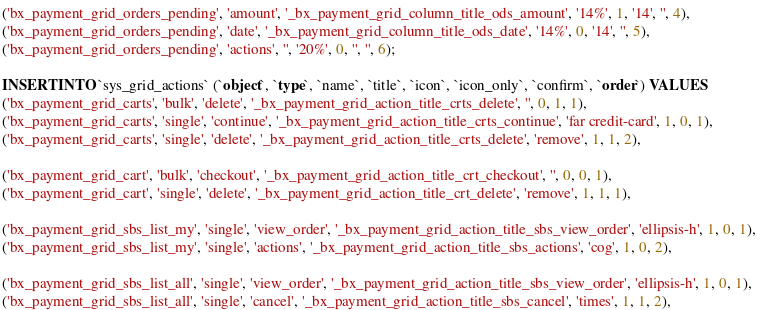Convert code to text. <code><loc_0><loc_0><loc_500><loc_500><_SQL_>('bx_payment_grid_orders_pending', 'amount', '_bx_payment_grid_column_title_ods_amount', '14%', 1, '14', '', 4),
('bx_payment_grid_orders_pending', 'date', '_bx_payment_grid_column_title_ods_date', '14%', 0, '14', '', 5),
('bx_payment_grid_orders_pending', 'actions', '', '20%', 0, '', '', 6);

INSERT INTO `sys_grid_actions` (`object`, `type`, `name`, `title`, `icon`, `icon_only`, `confirm`, `order`) VALUES
('bx_payment_grid_carts', 'bulk', 'delete', '_bx_payment_grid_action_title_crts_delete', '', 0, 1, 1),
('bx_payment_grid_carts', 'single', 'continue', '_bx_payment_grid_action_title_crts_continue', 'far credit-card', 1, 0, 1),
('bx_payment_grid_carts', 'single', 'delete', '_bx_payment_grid_action_title_crts_delete', 'remove', 1, 1, 2),

('bx_payment_grid_cart', 'bulk', 'checkout', '_bx_payment_grid_action_title_crt_checkout', '', 0, 0, 1),
('bx_payment_grid_cart', 'single', 'delete', '_bx_payment_grid_action_title_crt_delete', 'remove', 1, 1, 1),

('bx_payment_grid_sbs_list_my', 'single', 'view_order', '_bx_payment_grid_action_title_sbs_view_order', 'ellipsis-h', 1, 0, 1),
('bx_payment_grid_sbs_list_my', 'single', 'actions', '_bx_payment_grid_action_title_sbs_actions', 'cog', 1, 0, 2),

('bx_payment_grid_sbs_list_all', 'single', 'view_order', '_bx_payment_grid_action_title_sbs_view_order', 'ellipsis-h', 1, 0, 1),
('bx_payment_grid_sbs_list_all', 'single', 'cancel', '_bx_payment_grid_action_title_sbs_cancel', 'times', 1, 1, 2),
</code> 